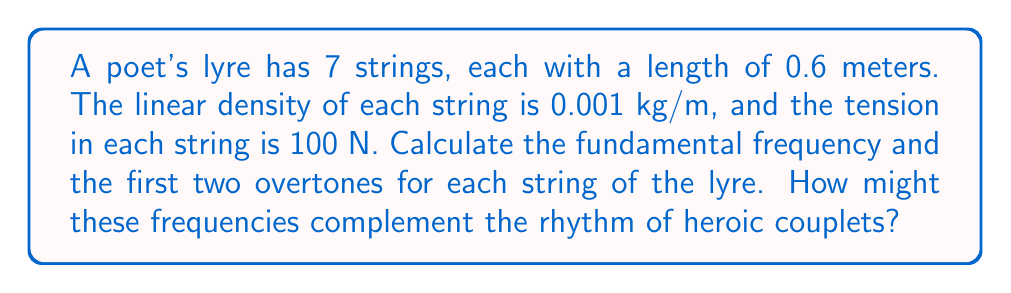Help me with this question. To solve this problem, we'll use the wave equation for a vibrating string:

$$f_n = \frac{n}{2L}\sqrt{\frac{T}{\mu}}$$

Where:
$f_n$ = frequency of the nth harmonic (Hz)
$n$ = harmonic number (1 for fundamental, 2 for first overtone, 3 for second overtone)
$L$ = length of the string (m)
$T$ = tension in the string (N)
$\mu$ = linear density of the string (kg/m)

Given:
$L = 0.6$ m
$T = 100$ N
$\mu = 0.001$ kg/m

Step 1: Calculate the fundamental frequency ($n = 1$)
$$f_1 = \frac{1}{2(0.6)}\sqrt{\frac{100}{0.001}} = 83.33 \text{ Hz}$$

Step 2: Calculate the first overtone ($n = 2$)
$$f_2 = \frac{2}{2(0.6)}\sqrt{\frac{100}{0.001}} = 166.67 \text{ Hz}$$

Step 3: Calculate the second overtone ($n = 3$)
$$f_3 = \frac{3}{2(0.6)}\sqrt{\frac{100}{0.001}} = 250 \text{ Hz}$$

These frequencies would complement heroic couplets by providing a harmonic backdrop. The fundamental frequency (83.33 Hz) could align with the meter of the couplets, while the overtones (166.67 Hz and 250 Hz) could emphasize key syllables or rhymes, enhancing the rhythmic structure of the verse.
Answer: Fundamental: 83.33 Hz, First overtone: 166.67 Hz, Second overtone: 250 Hz 